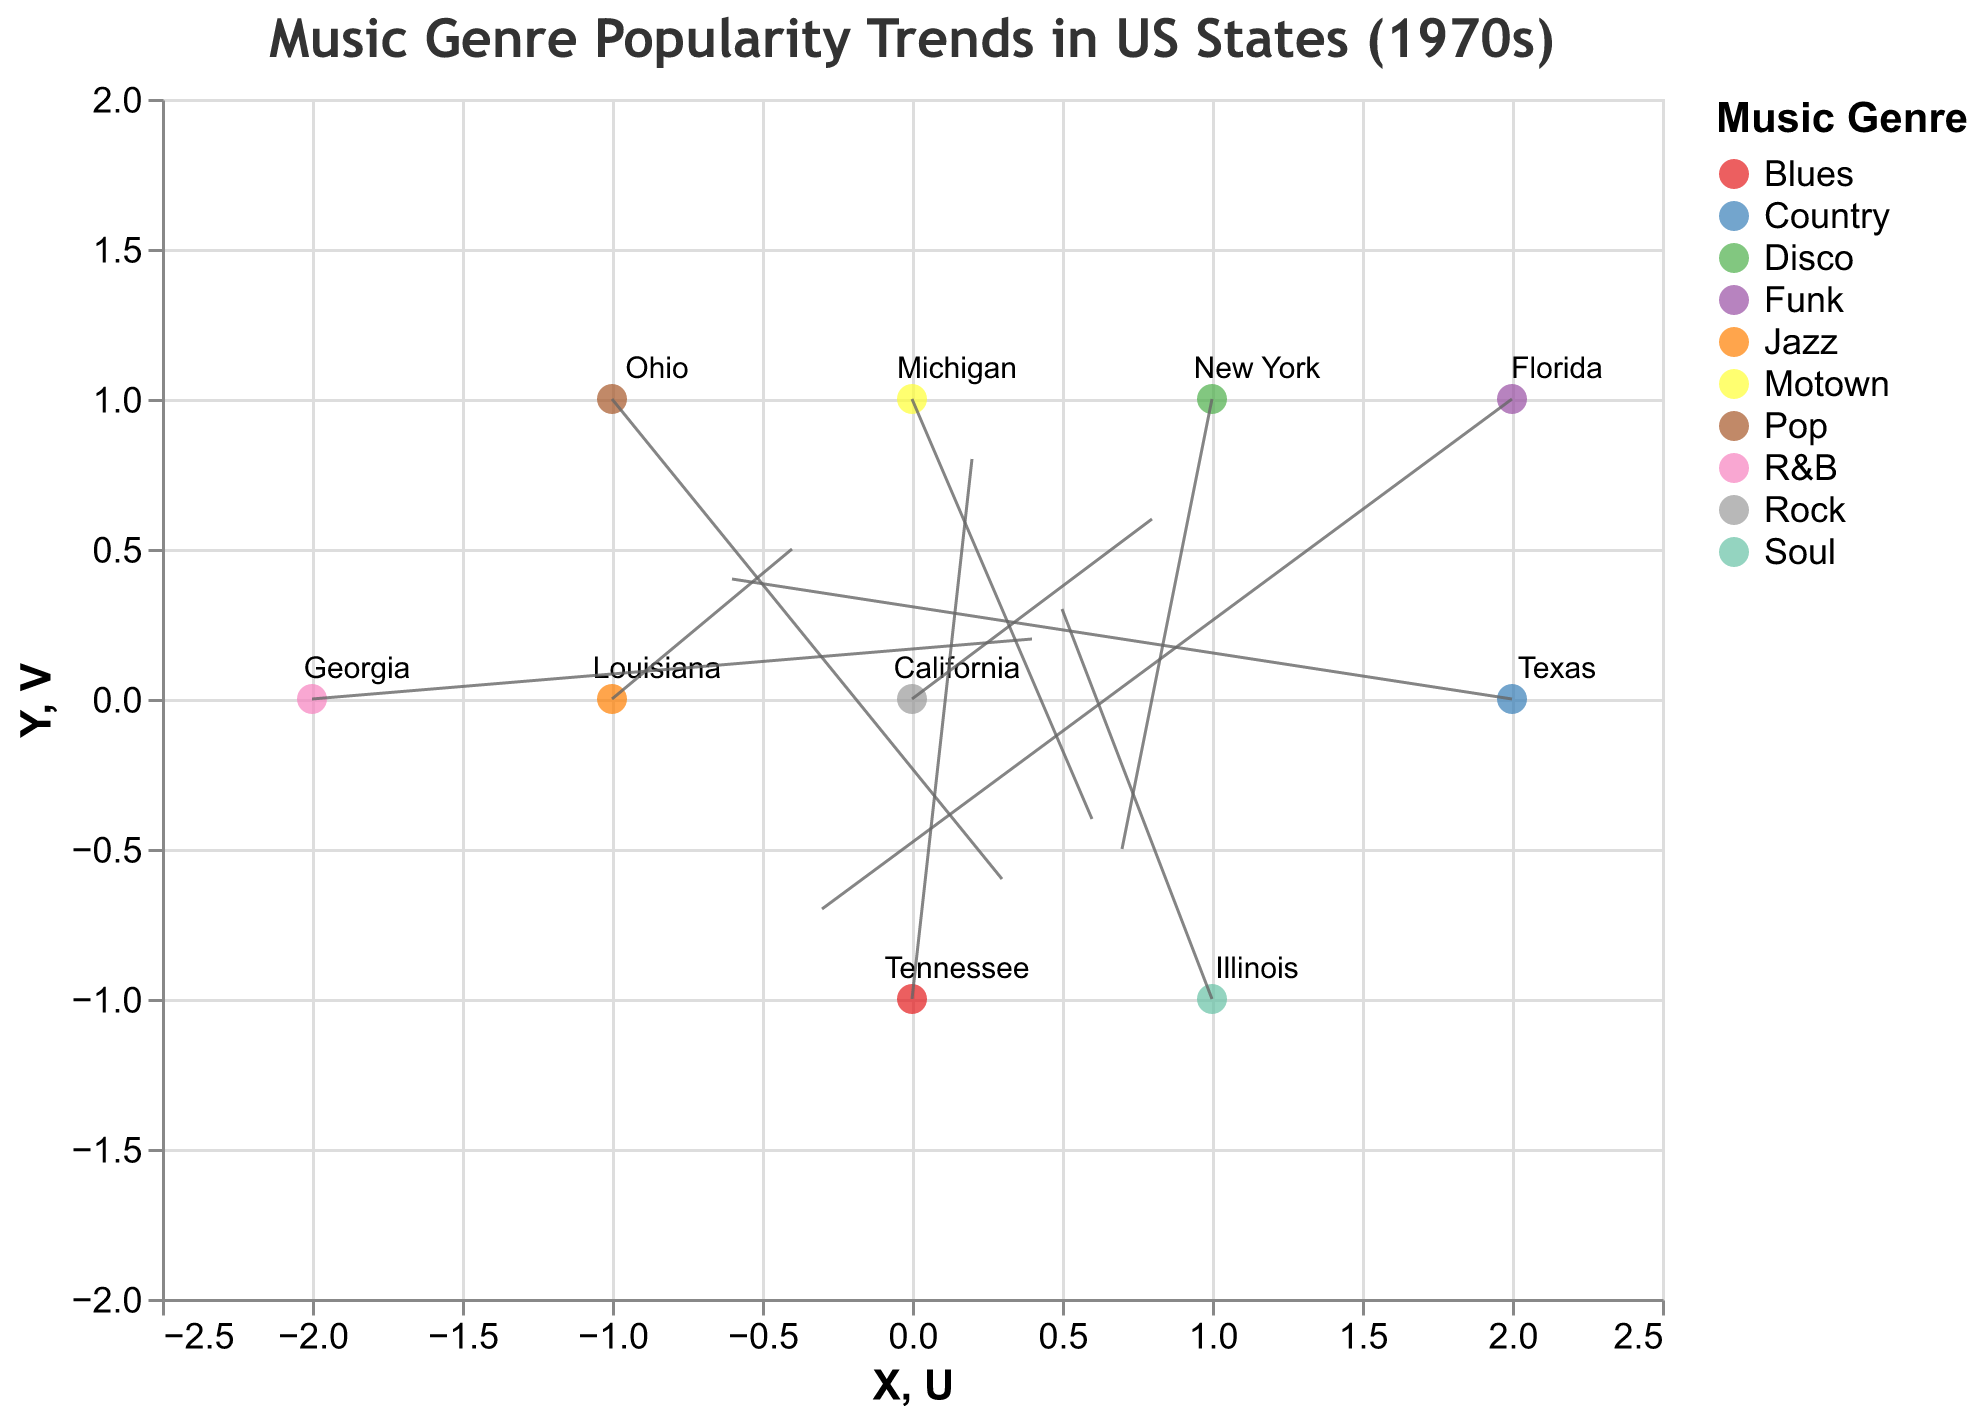What is the most popular music genre in California during the 1970s? The quiver plot shows each state's most popular music genre with a color legend. California's point and vector on the plot are color-coded.
Answer: Rock Which state has a music genre vector with both positive U and V components? States with both U and V values greater than 0 have vectors pointing up and to the right.
Answer: California, Illinois, Tennessee, Georgia Which genre was most popular in New York, and what was its directional trend? The plot marks New York at (1, 1) with a color-coded point. Its vector points down and to the right based on U and V values.
Answer: Disco, down and to the right Which state had its most popular genre trend upwards the most? The state's vector with the highest positive V value indicates the strongest upward trend. Examine all V components to identify the state.
Answer: Tennessee Compare the directional trends of Rock and Jazz. Which direction does each trend point toward? Identify the points and vectors for Rock and Jazz on the plot and inspect their vector directions.
Answer: Rock trends up and to the right (California), Jazz trends up and to the left (Louisiana) What states had music genres trending downwards, and what were the genres? States with vectors pointing downwards have negative V values. Identify them by checking V components of each state.
Answer: New York (Disco), Michigan (Motown), Ohio (Pop), Florida (Funk) What is the sum of the X coordinates for genres trending to the right? States trending to the right have positive U values. Sum the X coordinates of these states.
Answer: 1 + 1 + 0 - 2 = 0 Which state represents Funk, and in what direction is the genre trending? Identify the point marked "Florida" from the plot and the trend's direction.
Answer: Florida, down and slightly left How many states had a positive trend in U values? Count the number of states with a positive U component.
Answer: 6 states What music genre had the least upward trend in popularity, and for which state? Among states with positive V values, the genre with the smallest V component has the least upward trend.
Answer: Rock, California 